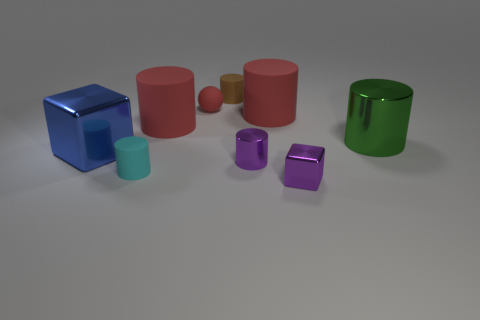Are there any small shiny blocks to the right of the small cyan matte object?
Provide a succinct answer. Yes. There is a red matte ball; is its size the same as the purple object in front of the cyan matte cylinder?
Your answer should be compact. Yes. There is a purple metallic object that is the same shape as the blue object; what size is it?
Your answer should be very brief. Small. Is there anything else that has the same material as the large blue block?
Offer a very short reply. Yes. Does the rubber cylinder that is to the right of the brown object have the same size as the shiny block that is right of the brown rubber thing?
Make the answer very short. No. What number of tiny objects are either rubber spheres or brown things?
Offer a terse response. 2. What number of tiny cylinders are right of the tiny brown matte cylinder and behind the large blue thing?
Your response must be concise. 0. Is the material of the cyan object the same as the cube right of the blue cube?
Offer a terse response. No. How many cyan things are either cylinders or tiny rubber cubes?
Give a very brief answer. 1. Are there any brown rubber cylinders that have the same size as the red sphere?
Keep it short and to the point. Yes. 